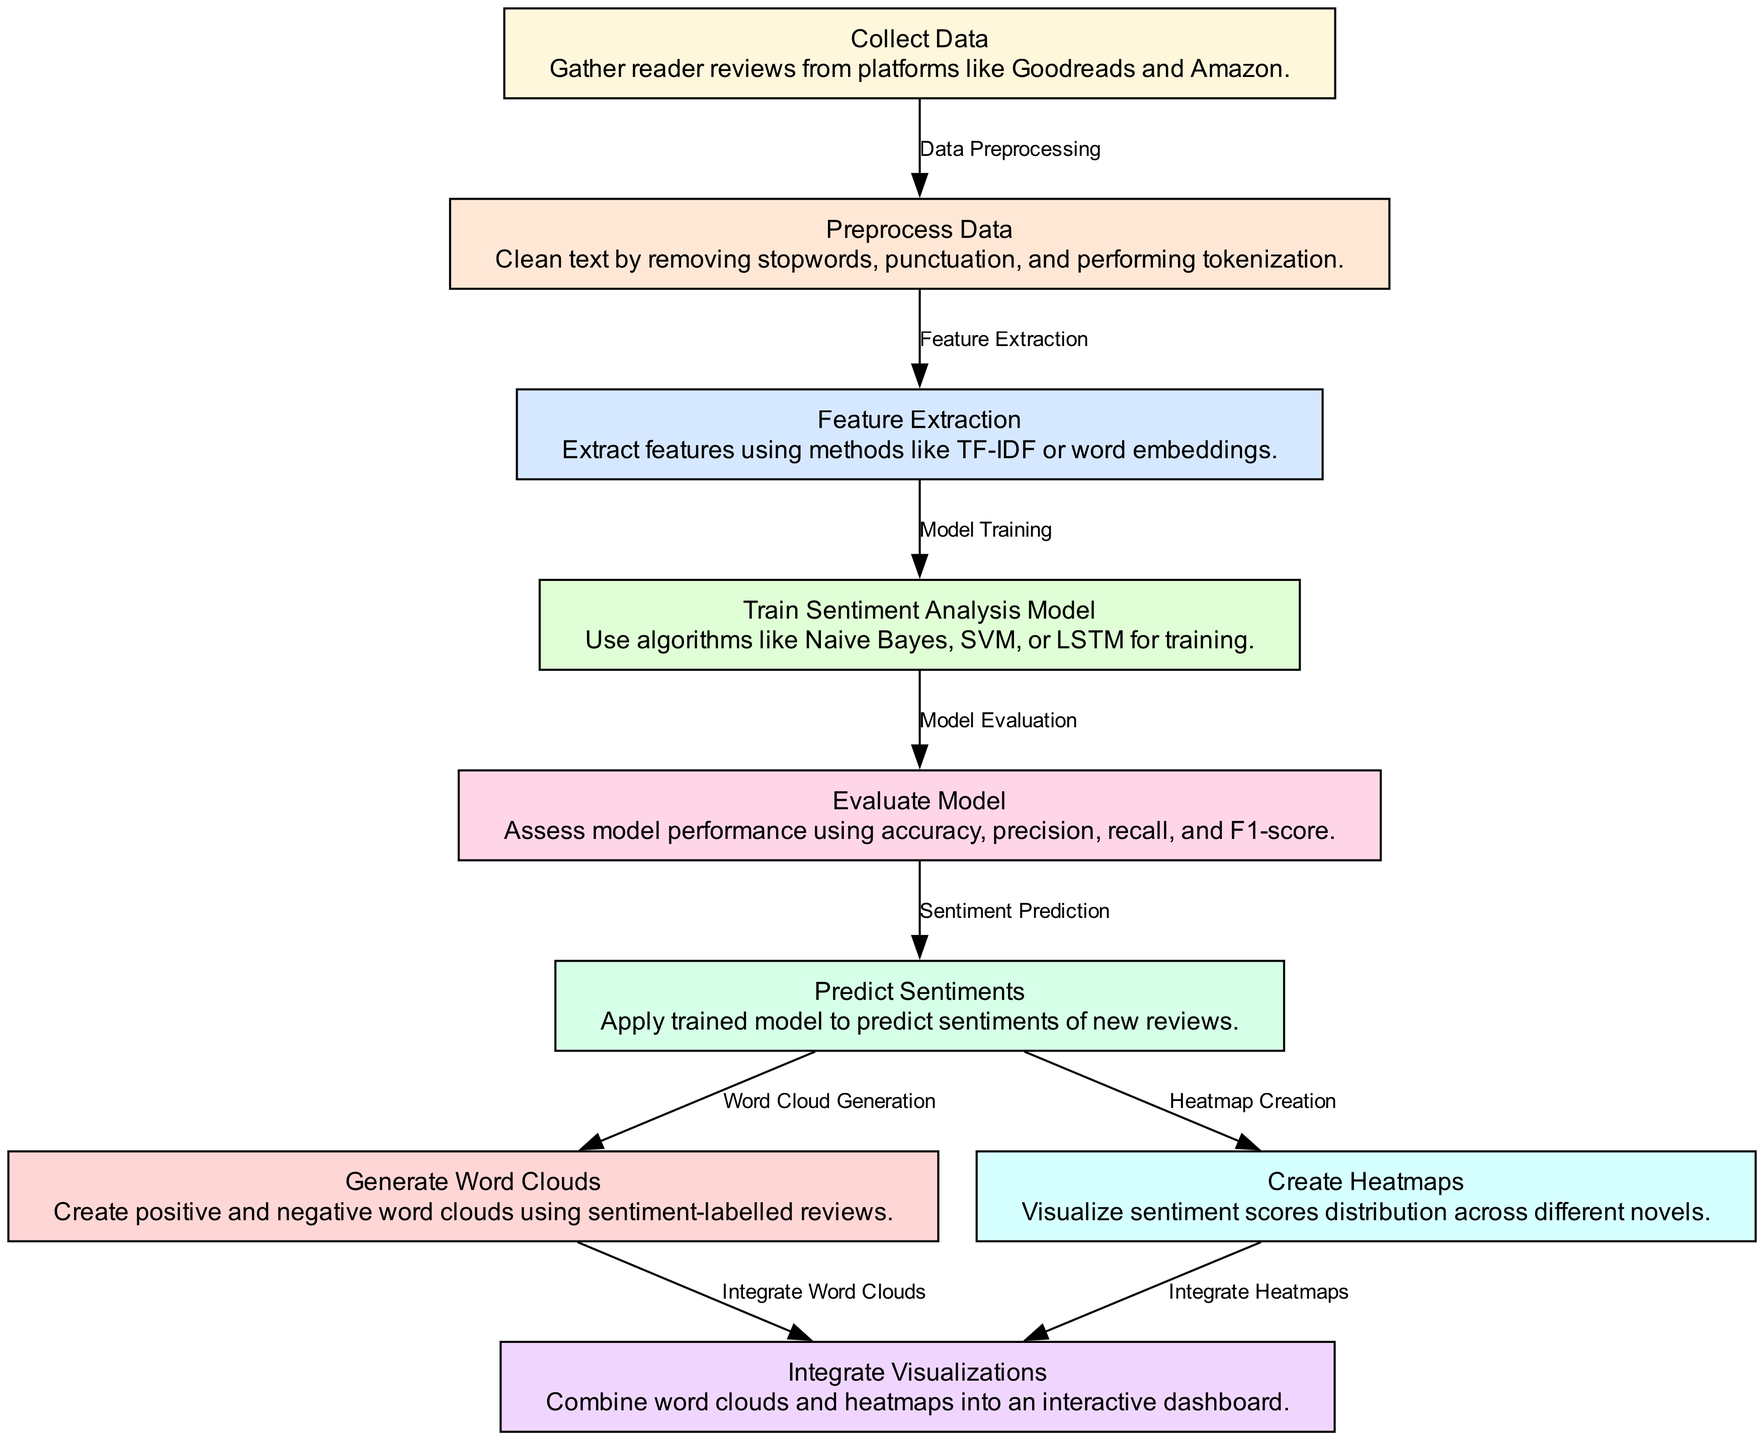What are the total number of nodes in the diagram? The nodes represent different stages in the sentiment analysis process, and counting them directly from the diagram shows there are nine nodes in total.
Answer: Nine Which node comes after "Train Sentiment Analysis Model"? The diagram shows a clear flow from "Train Sentiment Analysis Model" pointing to the "Evaluate Model" node, indicating that evaluation directly follows training.
Answer: Evaluate Model What process follows "Predict Sentiments"? After "Predict Sentiments," the diagram indicates two processes: "Generate Word Clouds" and "Create Heatmaps," which occur simultaneously as shown by two outgoing edges.
Answer: Generate Word Clouds, Create Heatmaps What is the main purpose of the "Integrate Visualizations" node? The "Integrate Visualizations" node combines the outputs from both "Generate Word Clouds" and "Create Heatmaps" into a cohesive interactive dashboard, as indicated by the edges leading into it.
Answer: Combine visual outputs How many edges are there in total? By examining the connections between the nodes, we can count the edges leading from one node to another. There are eight edges shown in the diagram, representing relationships between the different stages.
Answer: Eight Which method is used for feature extraction? The "Feature Extraction" node mentions extracting features using methods like TF-IDF or word embeddings, thus indicating these methods are employed in this step.
Answer: TF-IDF, word embeddings What steps are involved in data preprocessing? "Preprocess Data" is the node that entails cleaning text by removing stopwords, punctuation, and performing tokenization, clearly stating its procedures as outlined in the description.
Answer: Cleaning text What is the last step of the sentiment analysis workflow? The final step shown in the diagram is "Integrate Visualizations," marking the conclusion of the workflow where all outputs are combined, signifying the end of the analysis process.
Answer: Integrate Visualizations What type of visualizations are generated from the sentiment analysis? The outputs derived from the sentiment analysis process are both word clouds and heatmaps, as indicated in the nodes related to generating visual content from predictions.
Answer: Word clouds, heatmaps 